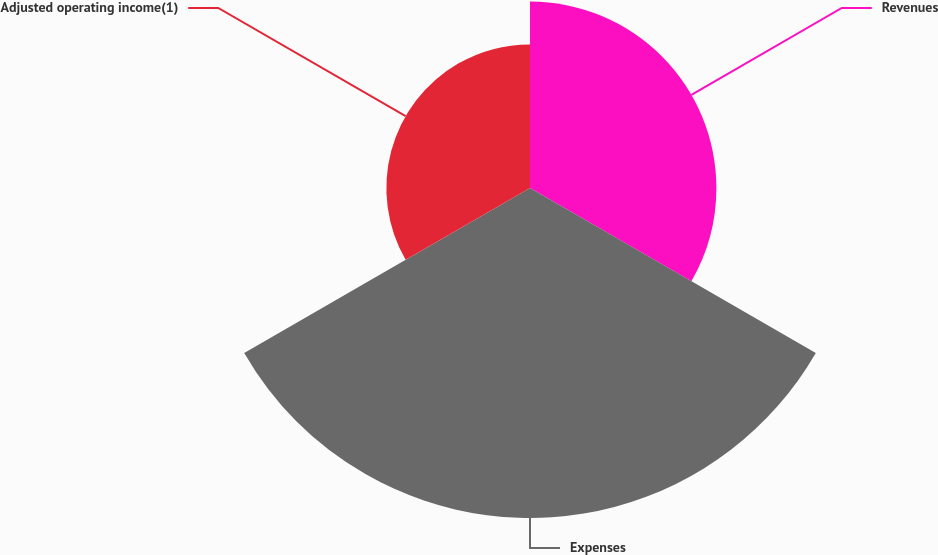Convert chart. <chart><loc_0><loc_0><loc_500><loc_500><pie_chart><fcel>Revenues<fcel>Expenses<fcel>Adjusted operating income(1)<nl><fcel>28.24%<fcel>50.0%<fcel>21.76%<nl></chart> 